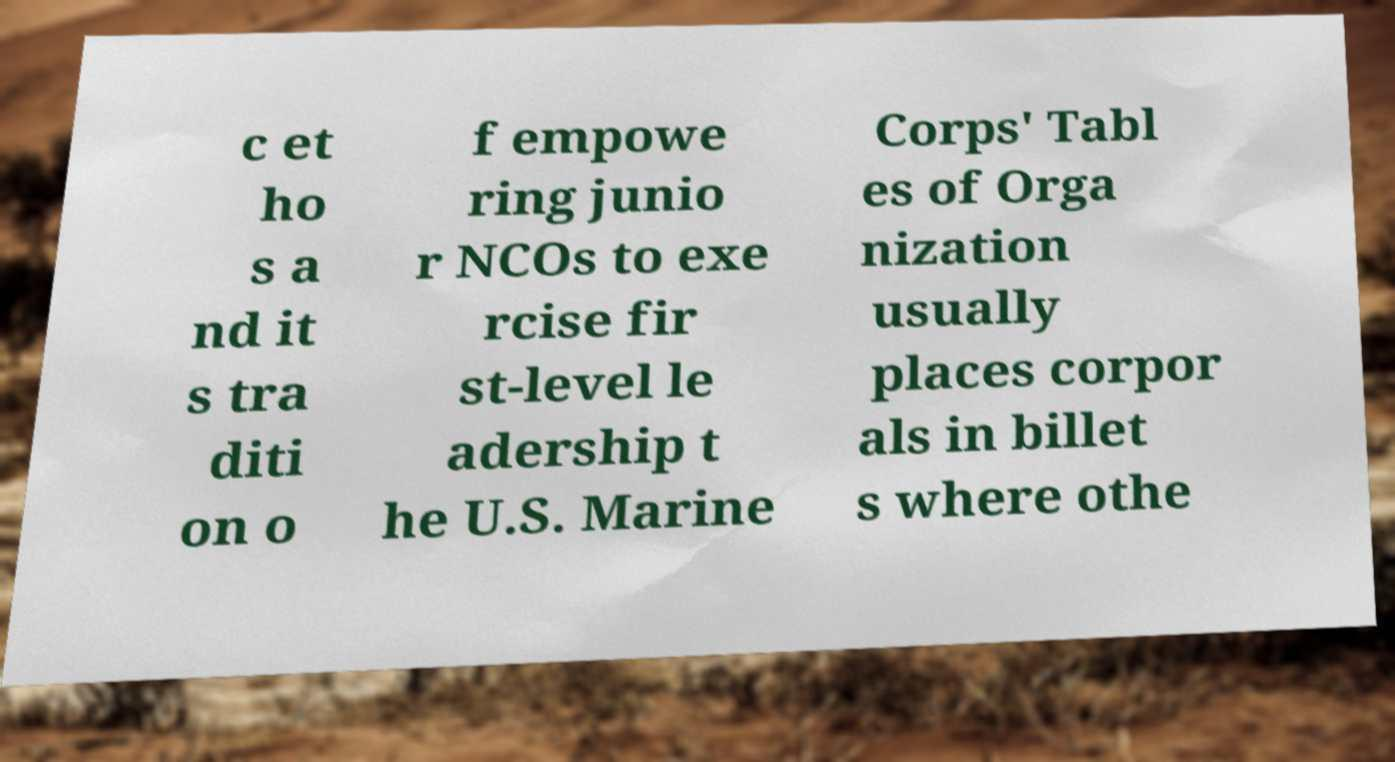Can you accurately transcribe the text from the provided image for me? c et ho s a nd it s tra diti on o f empowe ring junio r NCOs to exe rcise fir st-level le adership t he U.S. Marine Corps' Tabl es of Orga nization usually places corpor als in billet s where othe 